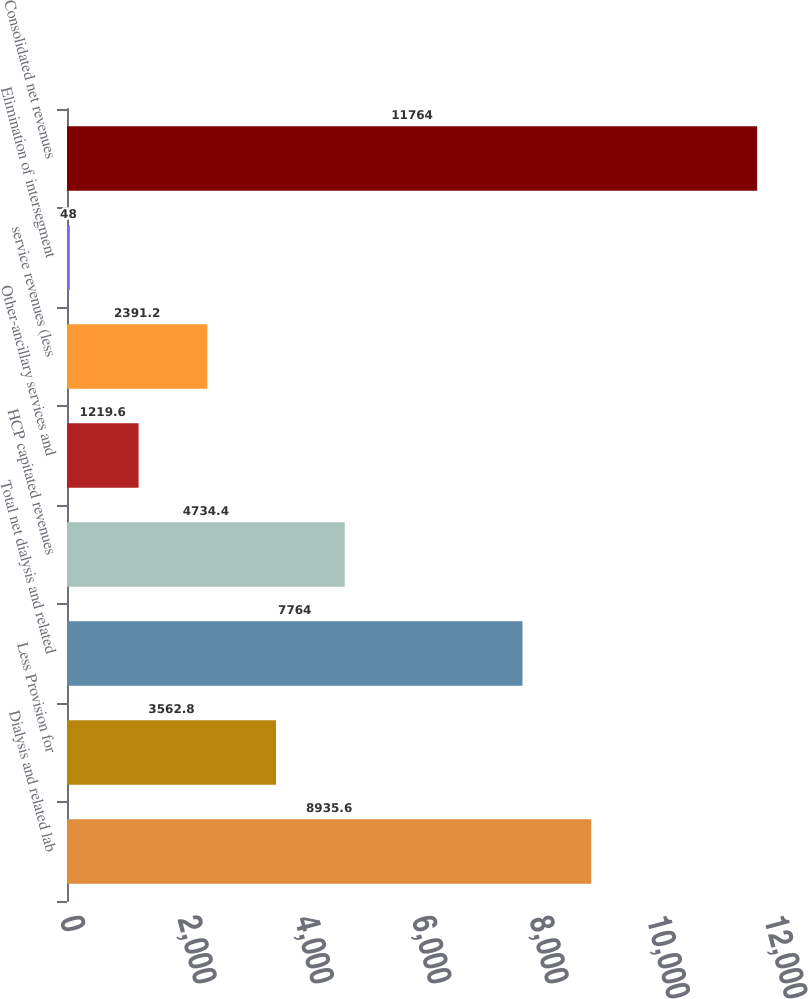Convert chart to OTSL. <chart><loc_0><loc_0><loc_500><loc_500><bar_chart><fcel>Dialysis and related lab<fcel>Less Provision for<fcel>Total net dialysis and related<fcel>HCP capitated revenues<fcel>Other-ancillary services and<fcel>service revenues (less<fcel>Elimination of intersegment<fcel>Consolidated net revenues<nl><fcel>8935.6<fcel>3562.8<fcel>7764<fcel>4734.4<fcel>1219.6<fcel>2391.2<fcel>48<fcel>11764<nl></chart> 